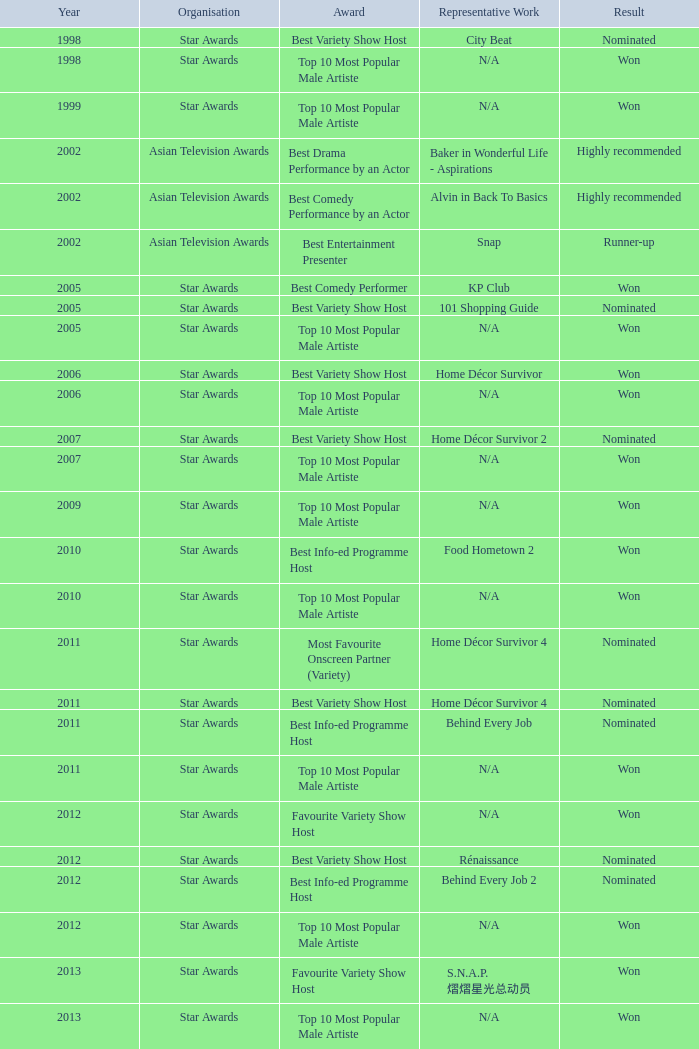What is the organisation in 2011 that was nominated and the award of best info-ed programme host? Star Awards. 